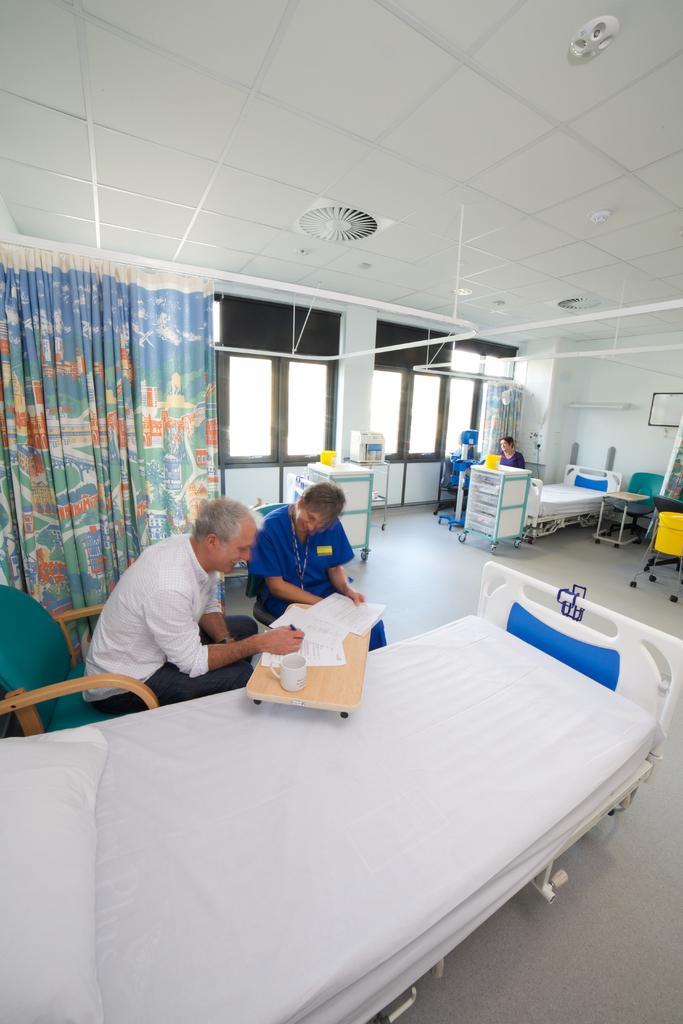How would you summarize this image in a sentence or two? In this image we can see two persons sitting on chairs. One person wearing a white t shirt is holding a pen in his hand. One women are wearing blue dress is holding a paper in her hand. In the middle of the image we can see a bed on which group of papers and a cup placed on the wooden tray. In the background ,we can see a woman sitting near a bed, a cupboard, curtains and a group of windows. 